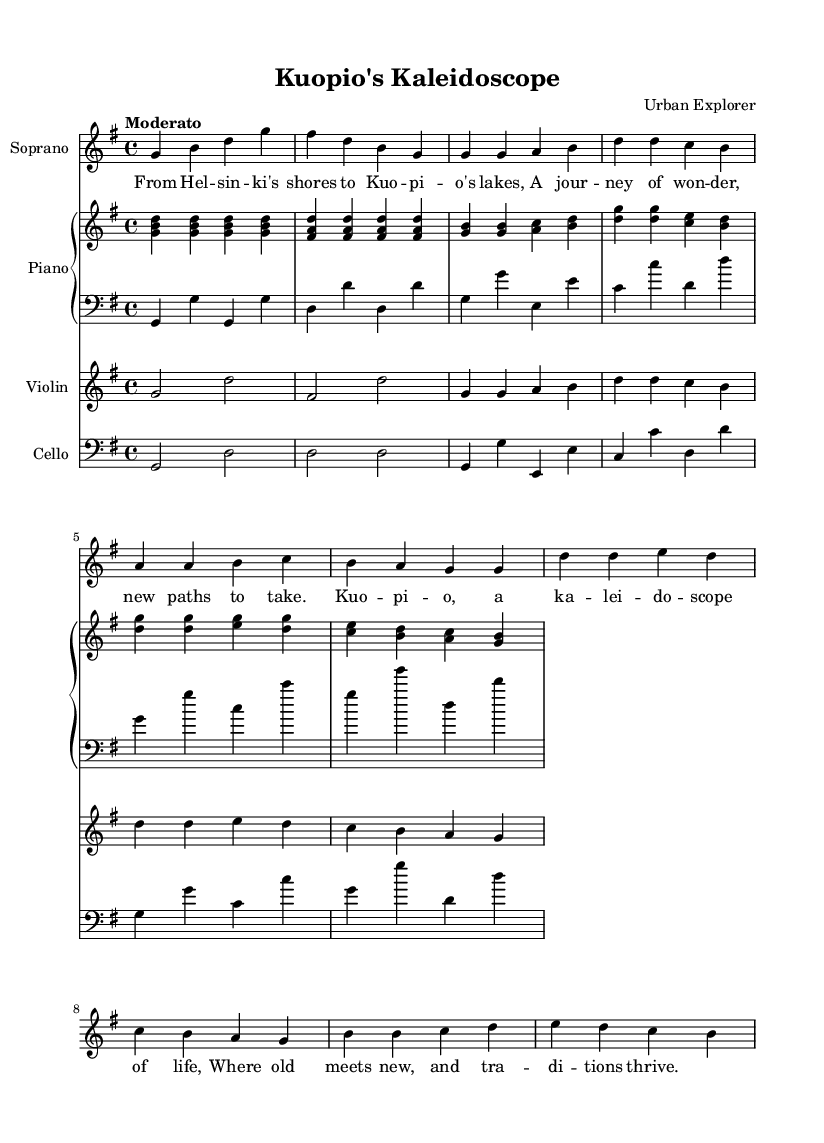What is the key signature of this music? The key signature is G major, which has one sharp (F#). You can identify the key signature at the beginning of the staff, where the sharps and flats are indicated.
Answer: G major What is the time signature of this music? The time signature is 4/4, which means there are four beats in each measure and the quarter note receives one beat. This information is located at the beginning of the score right after the key signature.
Answer: 4/4 What is the tempo marking of this music? The tempo marking is "Moderato," indicating a moderate speed for the piece. This is typically found above the staff, indicating the desired pace of the music.
Answer: Moderato How many measures are in the chorus section? The chorus section contains four measures. We can count the measures indicated by vertical lines on the staff that separate groups of notes. The notes and rests confirm there are four distinct measures in the chorus part.
Answer: 4 Which instrument plays the vocal line? The soprano plays the vocal line. The instrument is specified at the beginning of the score as Soprano, where the notes of the vocal melody are notated.
Answer: Soprano What is the melodic range of the soprano in the verse? The melodic range of the soprano in the verse extends from G to D in the fifth octave. By examining the notes in the soprano line during the verse, we can identify the highest and lowest notes to determine the range.
Answer: G to D In which voice does the cello part play? The cello part is in the bass clef. From the notation at the beginning of the cello staff, we can see that it uses the bass clef, which is characteristic of lower-pitched string instruments.
Answer: Bass clef 